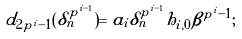<formula> <loc_0><loc_0><loc_500><loc_500>d _ { 2 p ^ { i } - 1 } ( \delta _ { n } ^ { p ^ { i - 1 } } ) = a _ { i } \delta _ { n } ^ { p ^ { i - 1 } } h _ { i , 0 } \beta ^ { p ^ { i } - 1 } ;</formula> 